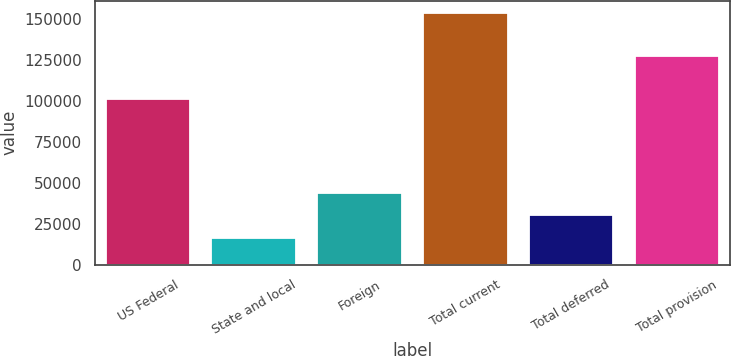<chart> <loc_0><loc_0><loc_500><loc_500><bar_chart><fcel>US Federal<fcel>State and local<fcel>Foreign<fcel>Total current<fcel>Total deferred<fcel>Total provision<nl><fcel>101092<fcel>16649<fcel>44060.4<fcel>153706<fcel>30354.7<fcel>127521<nl></chart> 